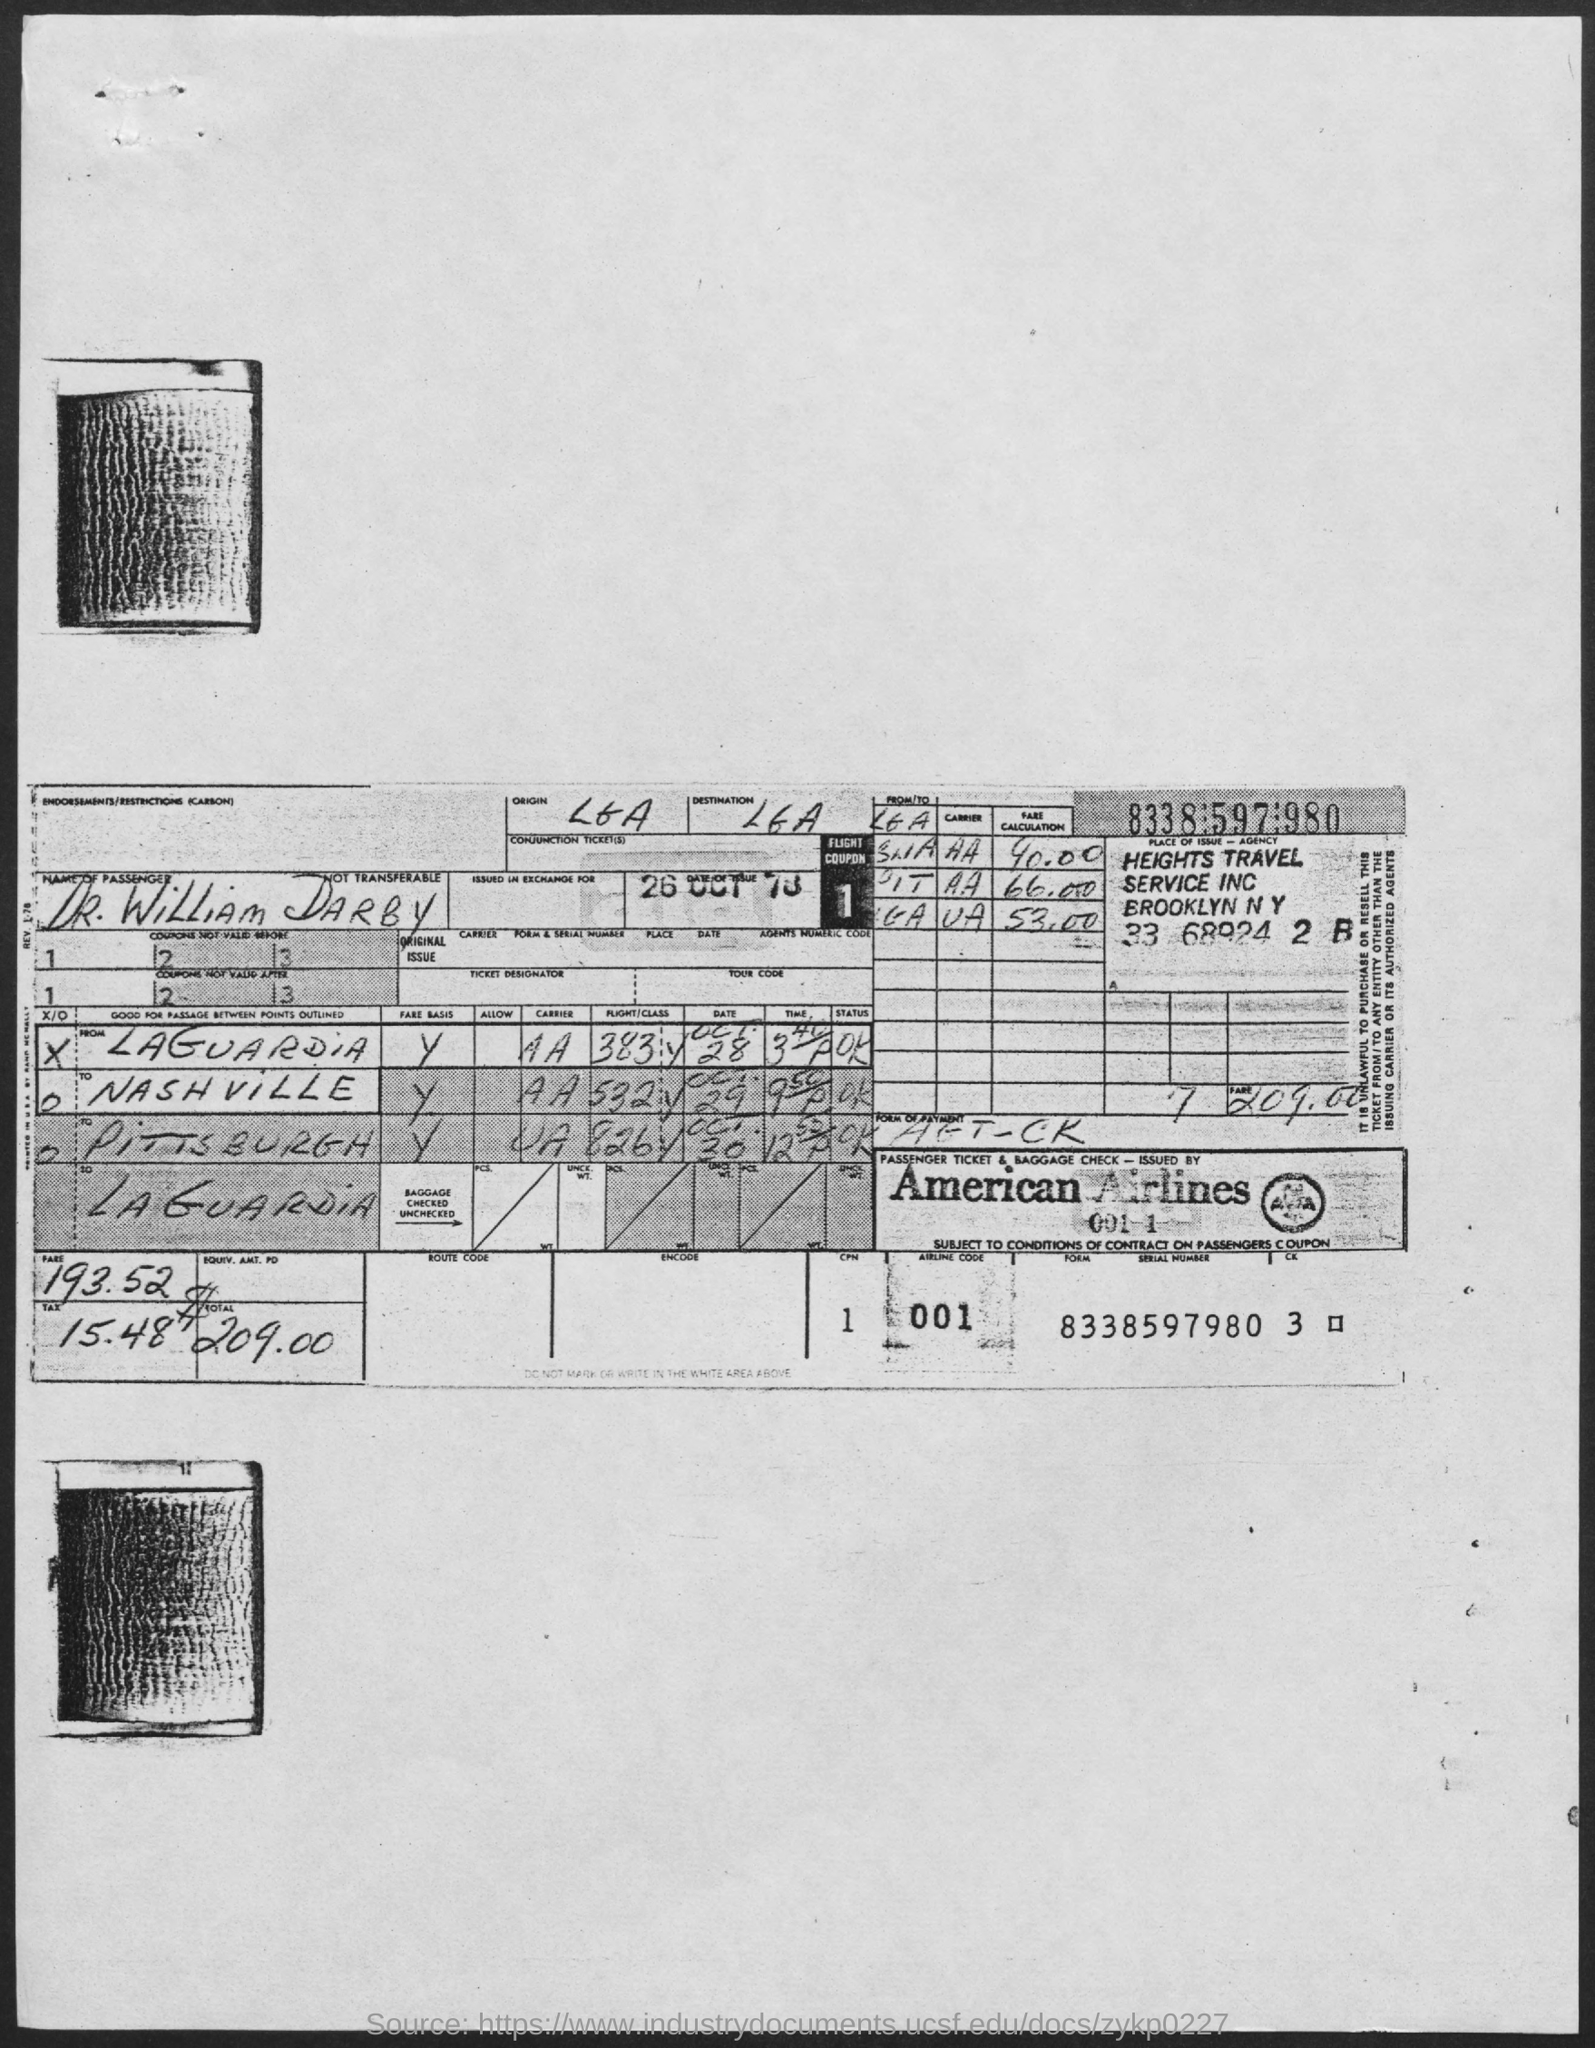Who issued the passenger ticket and baggage check?
Give a very brief answer. American Airlines. Who is the passenger?
Make the answer very short. DR. WiLLiAM DARBY. 